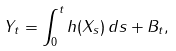Convert formula to latex. <formula><loc_0><loc_0><loc_500><loc_500>Y _ { t } = \int _ { 0 } ^ { t } h ( X _ { s } ) \, d s + B _ { t } ,</formula> 